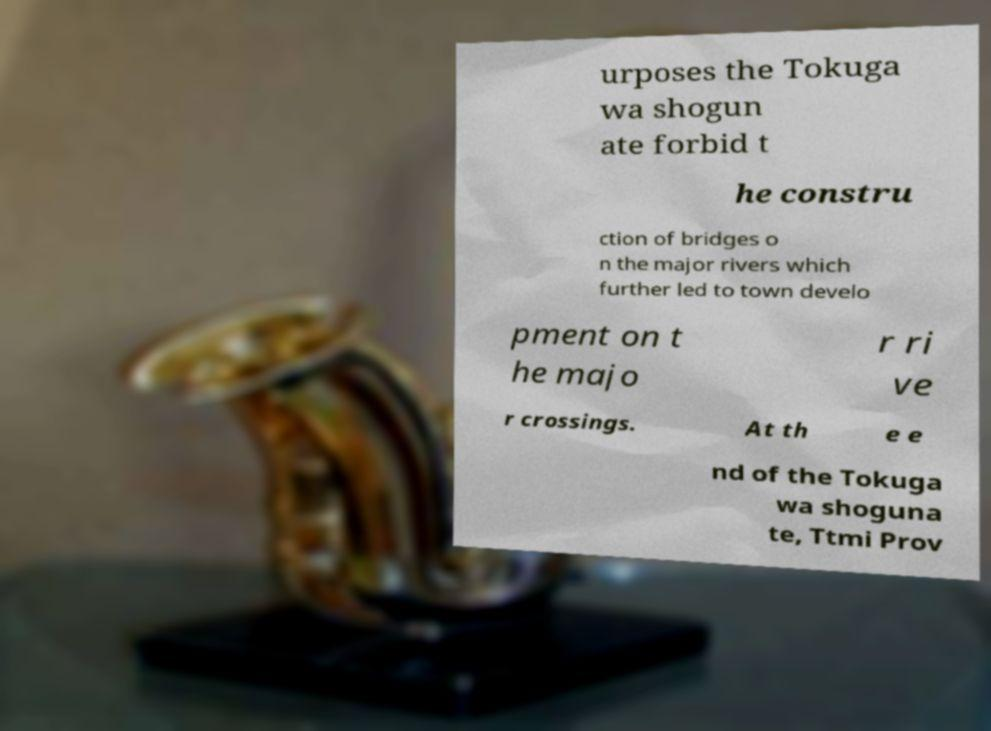What messages or text are displayed in this image? I need them in a readable, typed format. urposes the Tokuga wa shogun ate forbid t he constru ction of bridges o n the major rivers which further led to town develo pment on t he majo r ri ve r crossings. At th e e nd of the Tokuga wa shoguna te, Ttmi Prov 